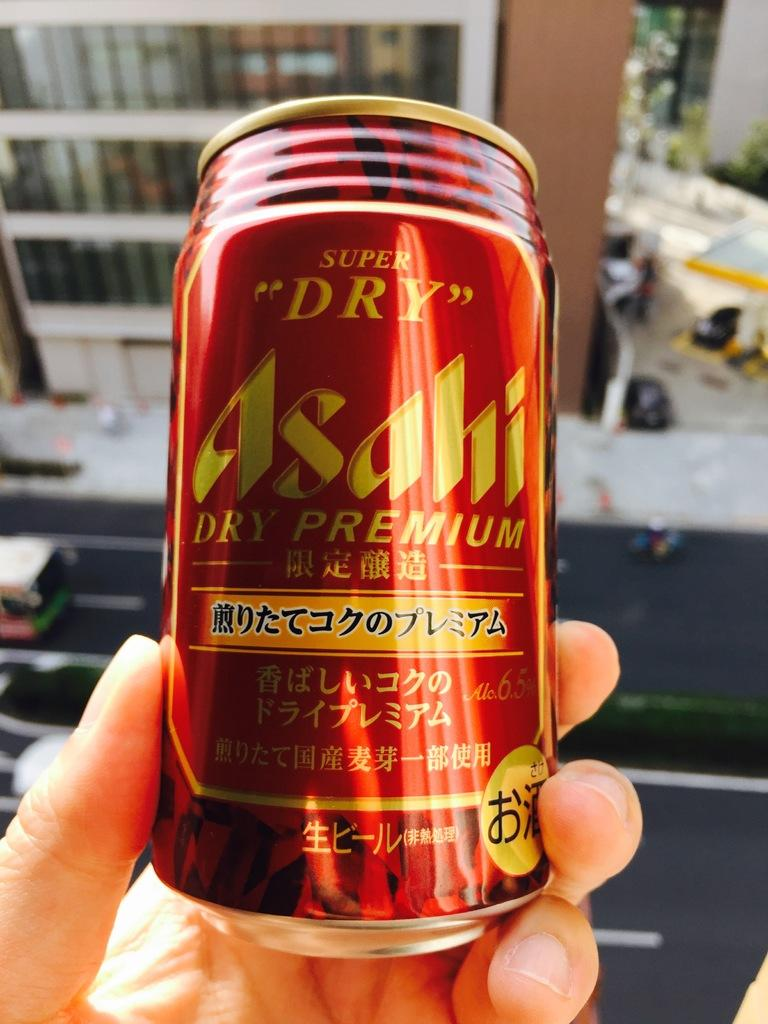<image>
Present a compact description of the photo's key features. The drink in the red tin claims to be super dry. 